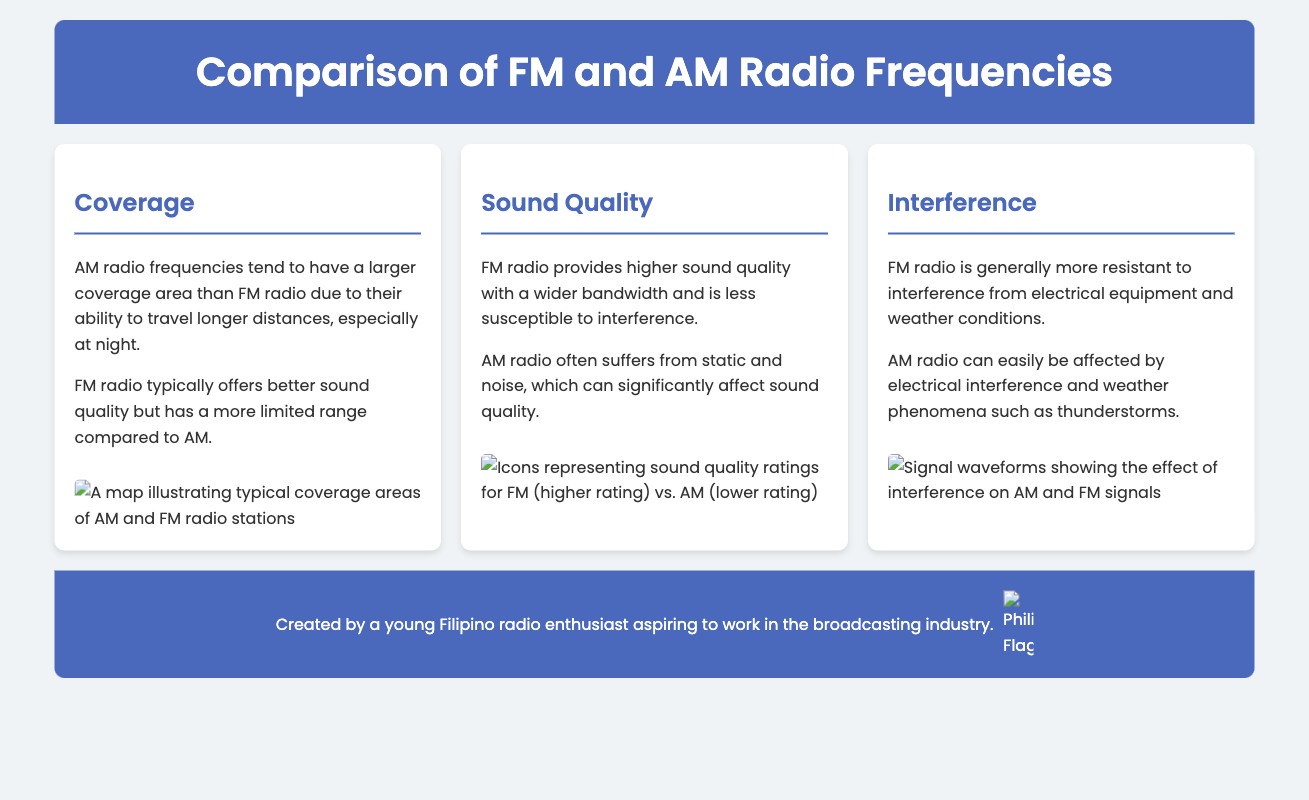What tends to have a larger coverage area, AM or FM? The document states that AM radio frequencies tend to have a larger coverage area than FM radio due to their ability to travel longer distances.
Answer: AM What provides higher sound quality, FM or AM? The document indicates that FM radio provides higher sound quality with a wider bandwidth.
Answer: FM Which radio frequency suffers more from static and noise? The document mentions that AM radio often suffers from static and noise, affecting sound quality.
Answer: AM How does FM radio generally perform in terms of interference? The document asserts that FM radio is generally more resistant to interference from electrical equipment and weather conditions.
Answer: More resistant What type of waveform is shown to illustrate interference effects? The document contains a description indicating that the signal waveforms show the effect of interference on AM and FM signals.
Answer: Signal waveforms What color is the header background in the infographic? The header background color is described as a specific shade of blue (hex code #4a69bd).
Answer: Blue 